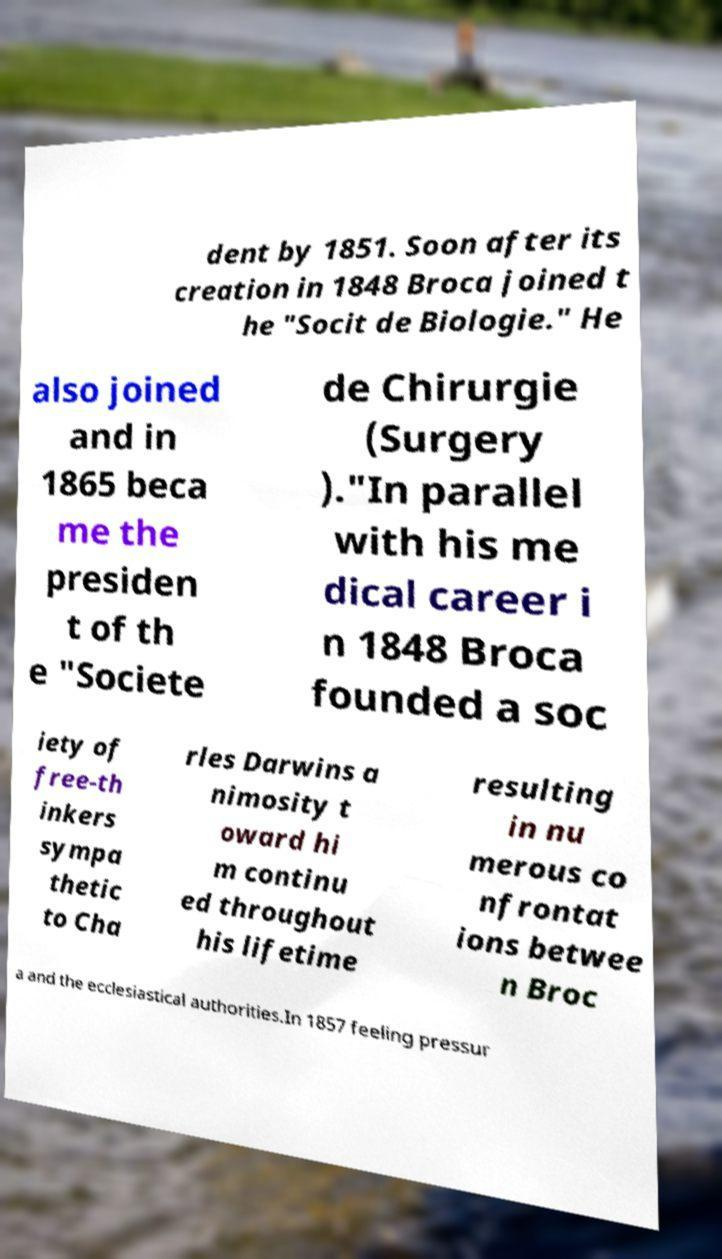Can you accurately transcribe the text from the provided image for me? dent by 1851. Soon after its creation in 1848 Broca joined t he "Socit de Biologie." He also joined and in 1865 beca me the presiden t of th e "Societe de Chirurgie (Surgery )."In parallel with his me dical career i n 1848 Broca founded a soc iety of free-th inkers sympa thetic to Cha rles Darwins a nimosity t oward hi m continu ed throughout his lifetime resulting in nu merous co nfrontat ions betwee n Broc a and the ecclesiastical authorities.In 1857 feeling pressur 